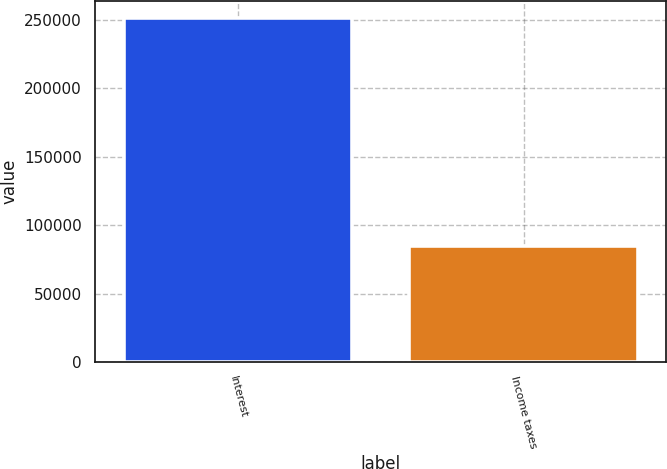Convert chart to OTSL. <chart><loc_0><loc_0><loc_500><loc_500><bar_chart><fcel>Interest<fcel>Income taxes<nl><fcel>251341<fcel>84984<nl></chart> 